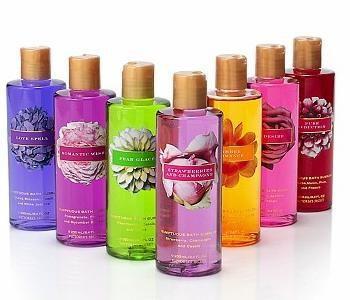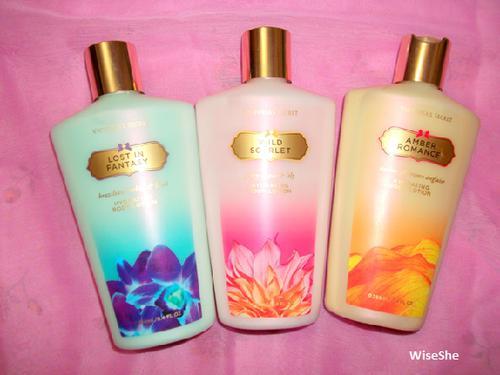The first image is the image on the left, the second image is the image on the right. For the images displayed, is the sentence "In one of the images there are seven containers lined up in a V shape." factually correct? Answer yes or no. Yes. 